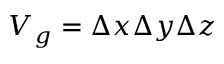Convert formula to latex. <formula><loc_0><loc_0><loc_500><loc_500>V _ { g } = \Delta x \Delta y \Delta z</formula> 